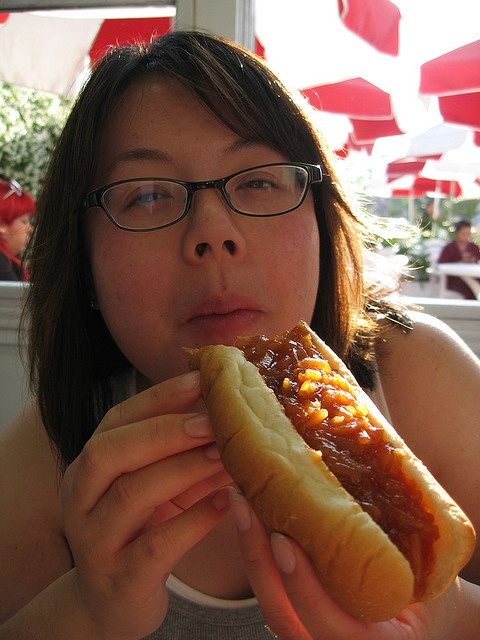Describe the objects in this image and their specific colors. I can see people in gray, maroon, black, and brown tones, sandwich in gray, maroon, brown, and olive tones, hot dog in gray, maroon, brown, and olive tones, umbrella in gray, white, and brown tones, and umbrella in gray, salmon, lightpink, and brown tones in this image. 